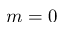<formula> <loc_0><loc_0><loc_500><loc_500>m = 0</formula> 